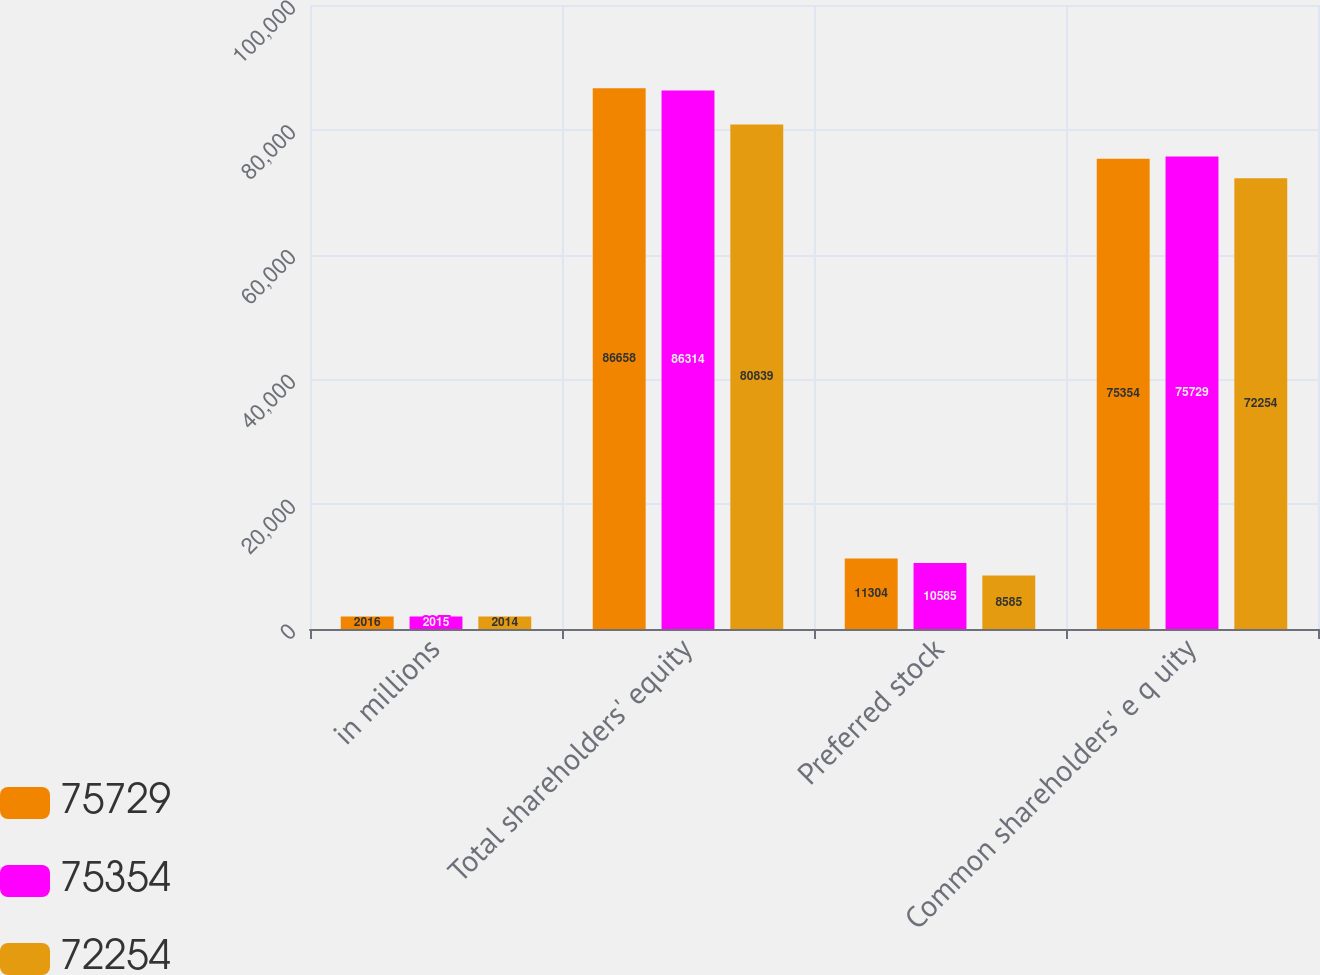<chart> <loc_0><loc_0><loc_500><loc_500><stacked_bar_chart><ecel><fcel>in millions<fcel>Total shareholders' equity<fcel>Preferred stock<fcel>Common shareholders' e q uity<nl><fcel>75729<fcel>2016<fcel>86658<fcel>11304<fcel>75354<nl><fcel>75354<fcel>2015<fcel>86314<fcel>10585<fcel>75729<nl><fcel>72254<fcel>2014<fcel>80839<fcel>8585<fcel>72254<nl></chart> 